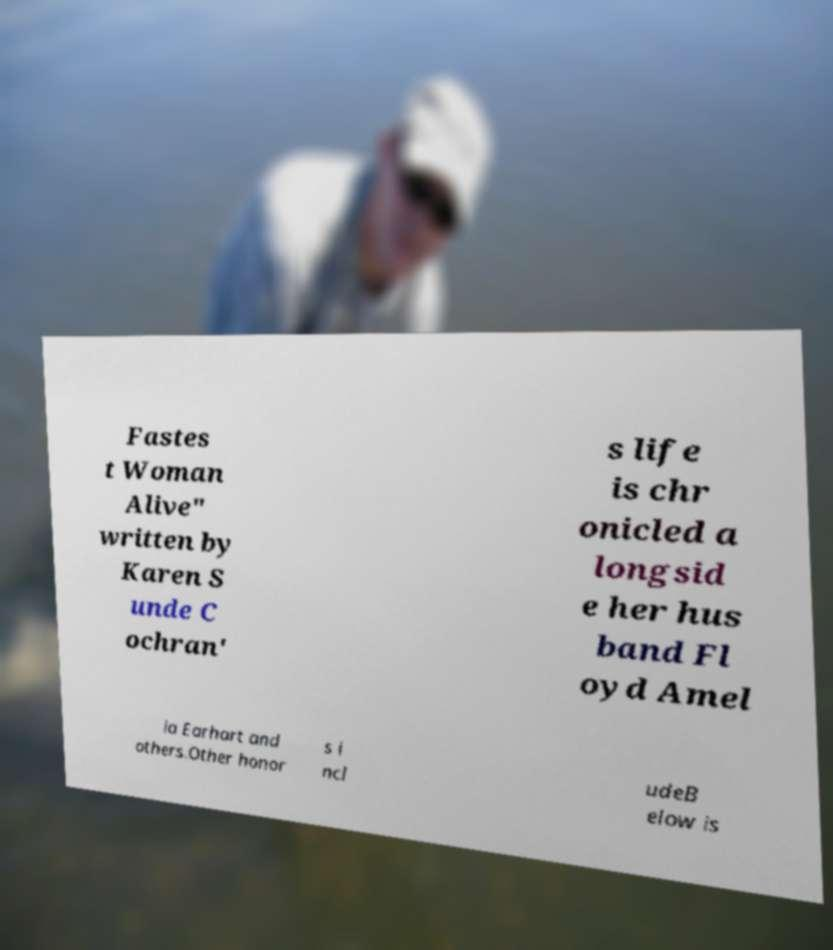There's text embedded in this image that I need extracted. Can you transcribe it verbatim? Fastes t Woman Alive" written by Karen S unde C ochran' s life is chr onicled a longsid e her hus band Fl oyd Amel ia Earhart and others.Other honor s i ncl udeB elow is 